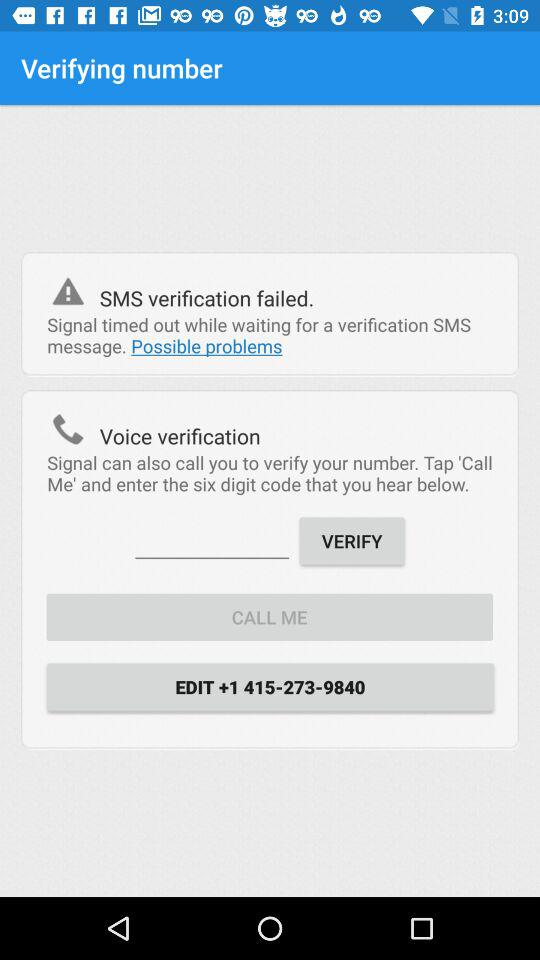How many digits are in the verification code?
Answer the question using a single word or phrase. 6 